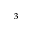Convert formula to latex. <formula><loc_0><loc_0><loc_500><loc_500>_ { 3 }</formula> 